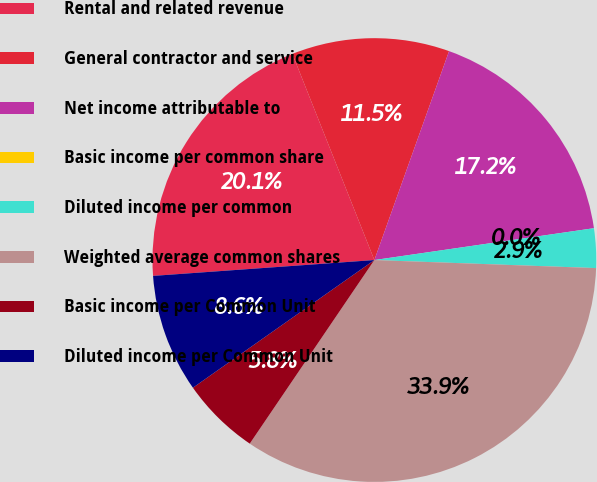Convert chart. <chart><loc_0><loc_0><loc_500><loc_500><pie_chart><fcel>Rental and related revenue<fcel>General contractor and service<fcel>Net income attributable to<fcel>Basic income per common share<fcel>Diluted income per common<fcel>Weighted average common shares<fcel>Basic income per Common Unit<fcel>Diluted income per Common Unit<nl><fcel>20.11%<fcel>11.49%<fcel>17.24%<fcel>0.0%<fcel>2.87%<fcel>33.91%<fcel>5.75%<fcel>8.62%<nl></chart> 